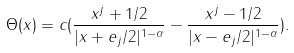Convert formula to latex. <formula><loc_0><loc_0><loc_500><loc_500>\Theta ( x ) = c ( \frac { x ^ { j } + 1 / 2 } { | x + e _ { j } / 2 | ^ { 1 - \alpha } } - \frac { x ^ { j } - 1 / 2 } { | x - e _ { j } / 2 | ^ { 1 - \alpha } } ) .</formula> 